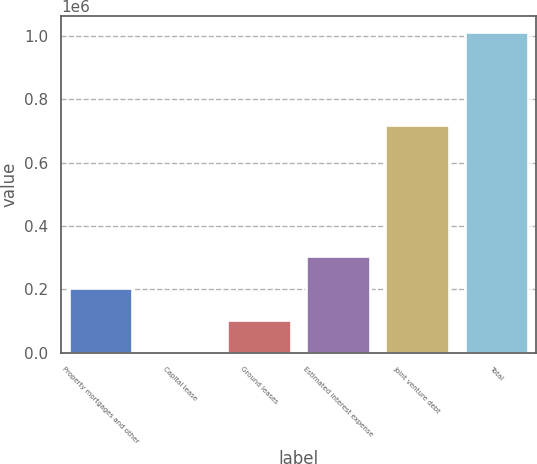<chart> <loc_0><loc_0><loc_500><loc_500><bar_chart><fcel>Property mortgages and other<fcel>Capital lease<fcel>Ground leases<fcel>Estimated interest expense<fcel>Joint venture debt<fcel>Total<nl><fcel>204222<fcel>2411<fcel>103317<fcel>305128<fcel>717682<fcel>1.01147e+06<nl></chart> 